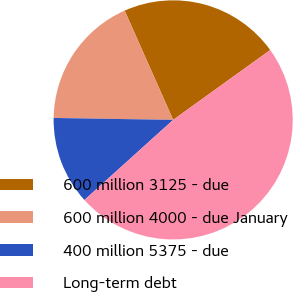Convert chart to OTSL. <chart><loc_0><loc_0><loc_500><loc_500><pie_chart><fcel>600 million 3125 - due<fcel>600 million 4000 - due January<fcel>400 million 5375 - due<fcel>Long-term debt<nl><fcel>21.72%<fcel>18.09%<fcel>11.94%<fcel>48.24%<nl></chart> 